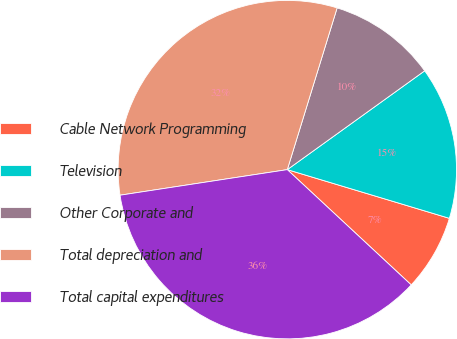<chart> <loc_0><loc_0><loc_500><loc_500><pie_chart><fcel>Cable Network Programming<fcel>Television<fcel>Other Corporate and<fcel>Total depreciation and<fcel>Total capital expenditures<nl><fcel>7.28%<fcel>14.57%<fcel>10.32%<fcel>32.17%<fcel>35.66%<nl></chart> 